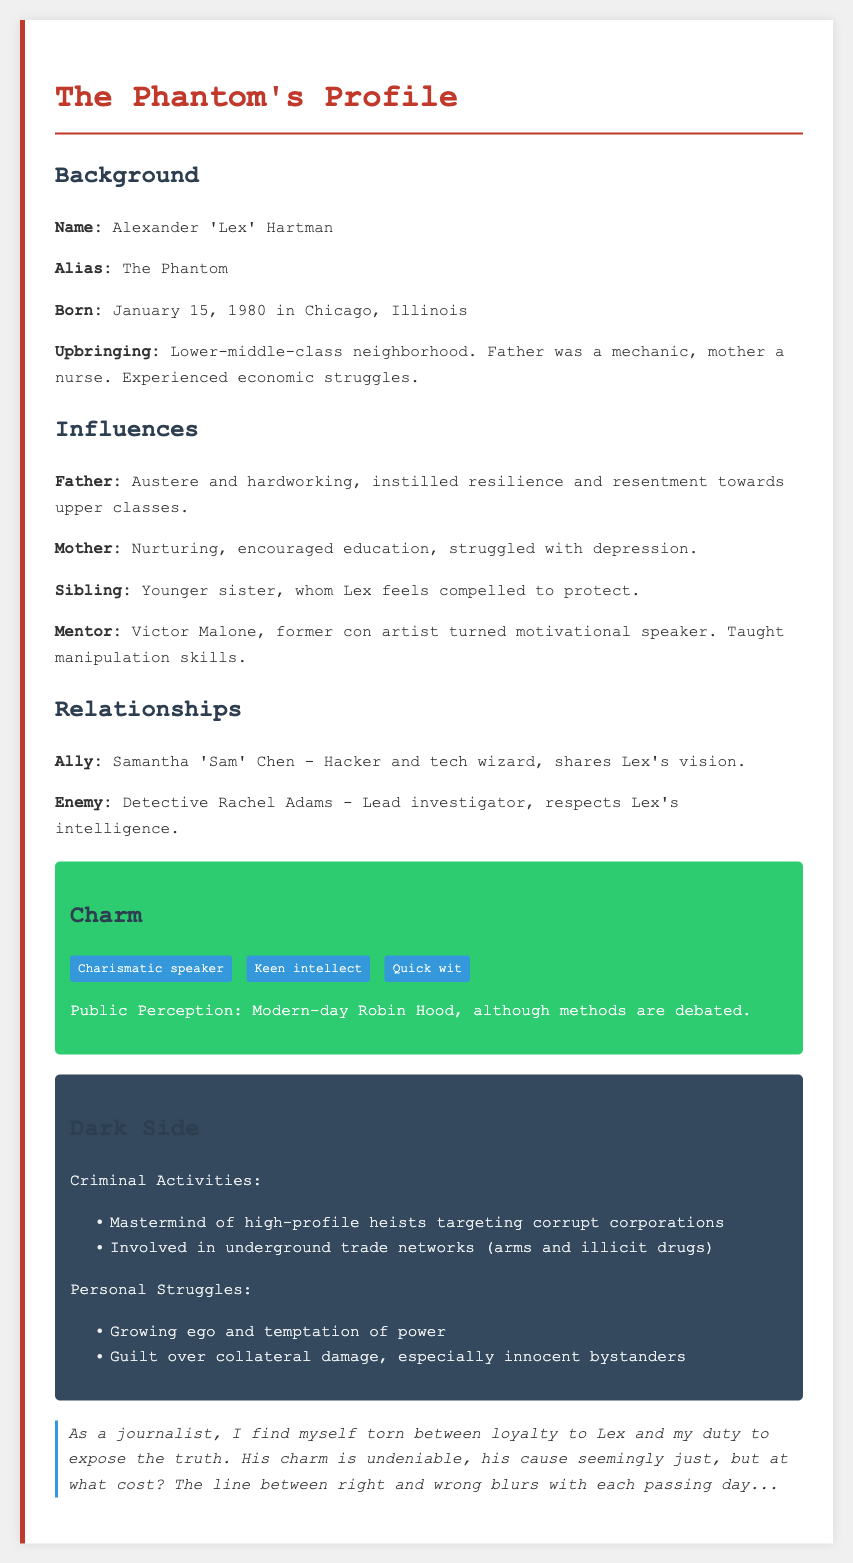What is the real name of the master criminal? The real name of the master criminal is mentioned in the background section of the document.
Answer: Alexander 'Lex' Hartman What is Lex's alias? Lex's alias is highlighted under the background section of the document.
Answer: The Phantom When was Lex born? Lex's birth date is specified in the background information.
Answer: January 15, 1980 Who is Lex's mentor? The mentor that played a significant role in Lex's life is listed in the influences section.
Answer: Victor Malone What profession did Lex's mother have? Lex's mother's occupation is stated in the background section.
Answer: Nurse What characteristic describes Lex as a public figure? The public perception of Lex is discussed in the charm section.
Answer: Modern-day Robin Hood What type of crimes has Lex committed? The types of criminal activities Lex is involved in are outlined in the dark side section.
Answer: High-profile heists and underground trade Who is Lex's enemy? Lex's main adversary is mentioned in the relationships section.
Answer: Detective Rachel Adams What is Lex's guilty struggle related to? The personal struggles section identifies the emotional conflict Lex faces.
Answer: Guilt over collateral damage 